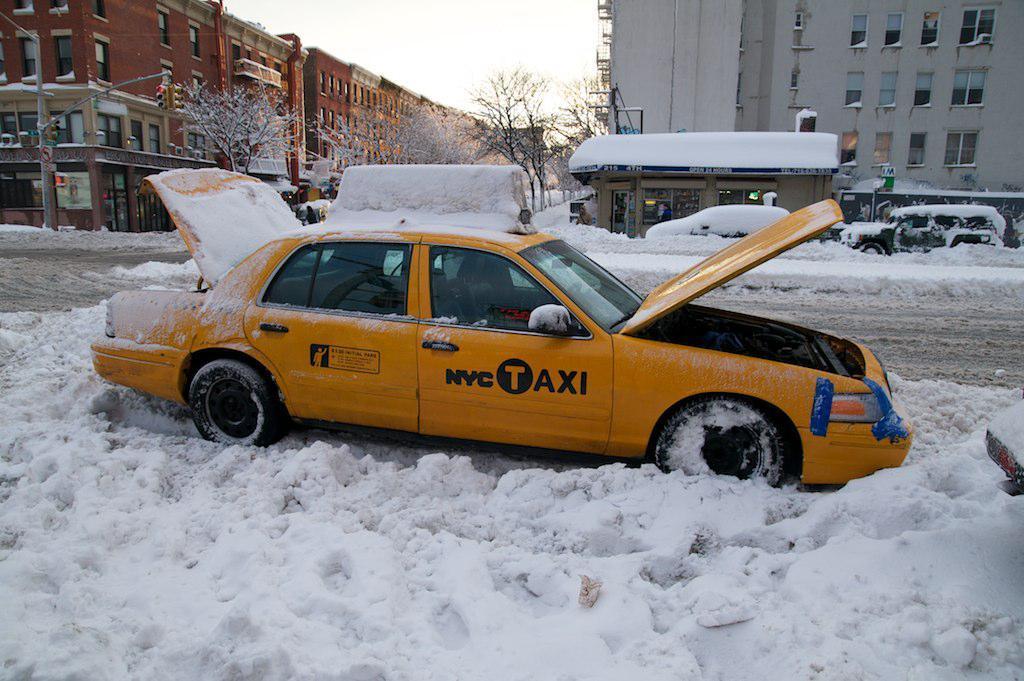Describe this image in one or two sentences. In this image we can see a car parked on the snow. In the background, we can see group of vehicles parked on the road, a group of buildings, trees and the sky. 